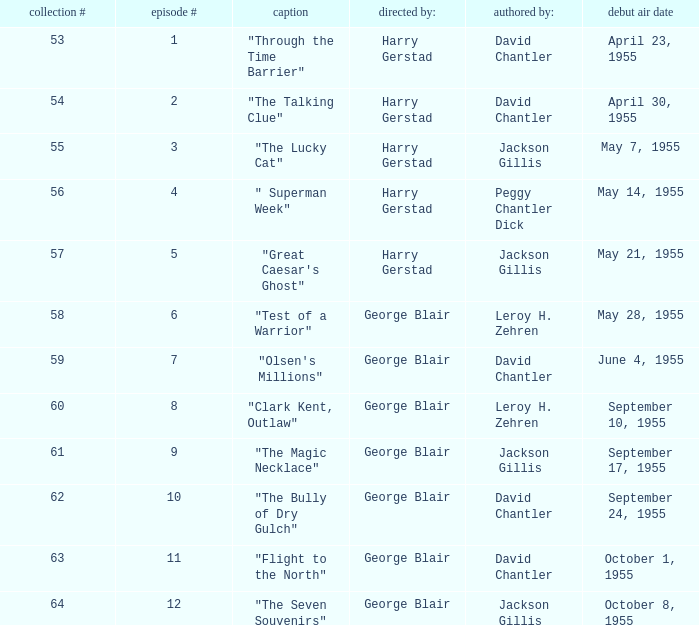Who was "The Magic Necklace" written by? Jackson Gillis. 